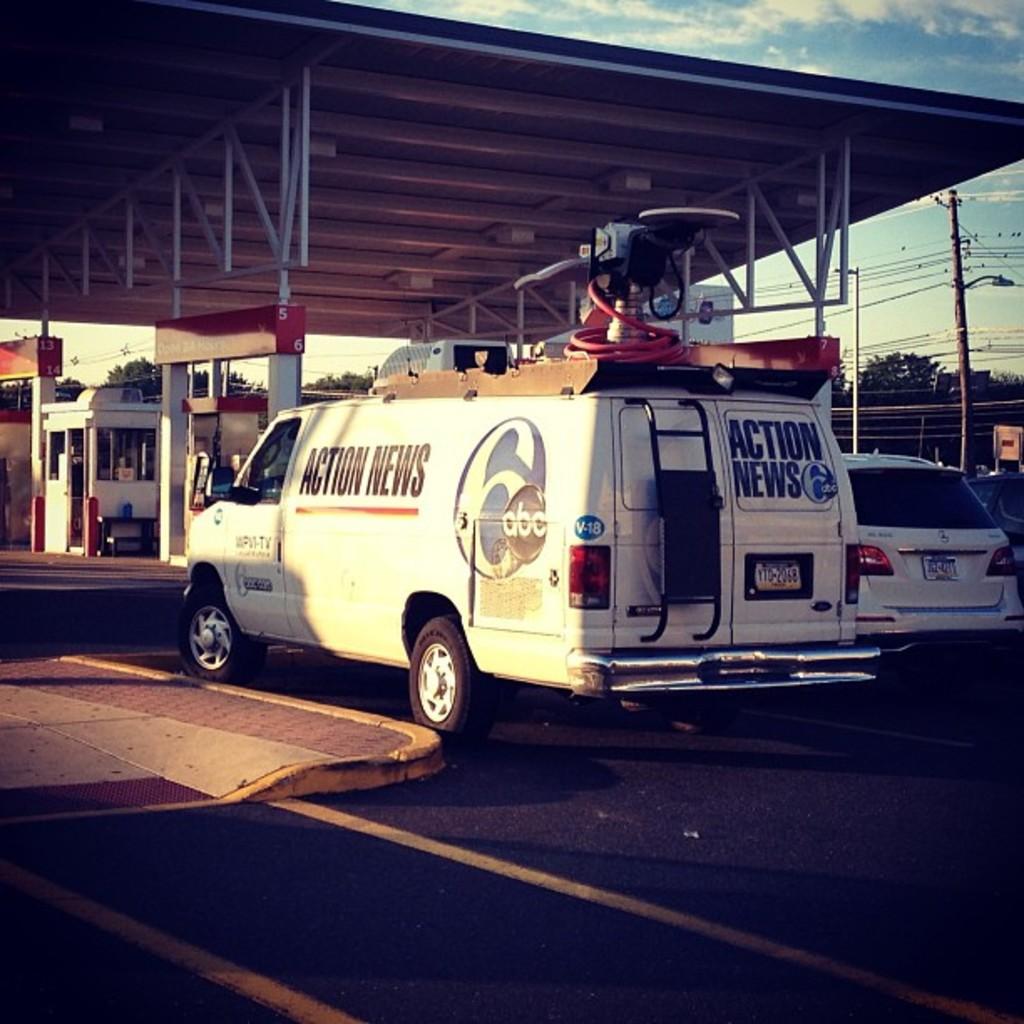What channel is the news van from?
Keep it short and to the point. 6. 